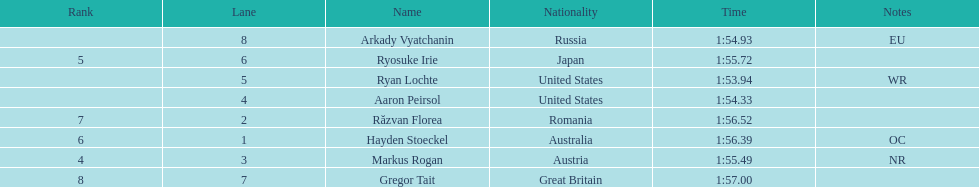Which country had the most medals in the competition? United States. 